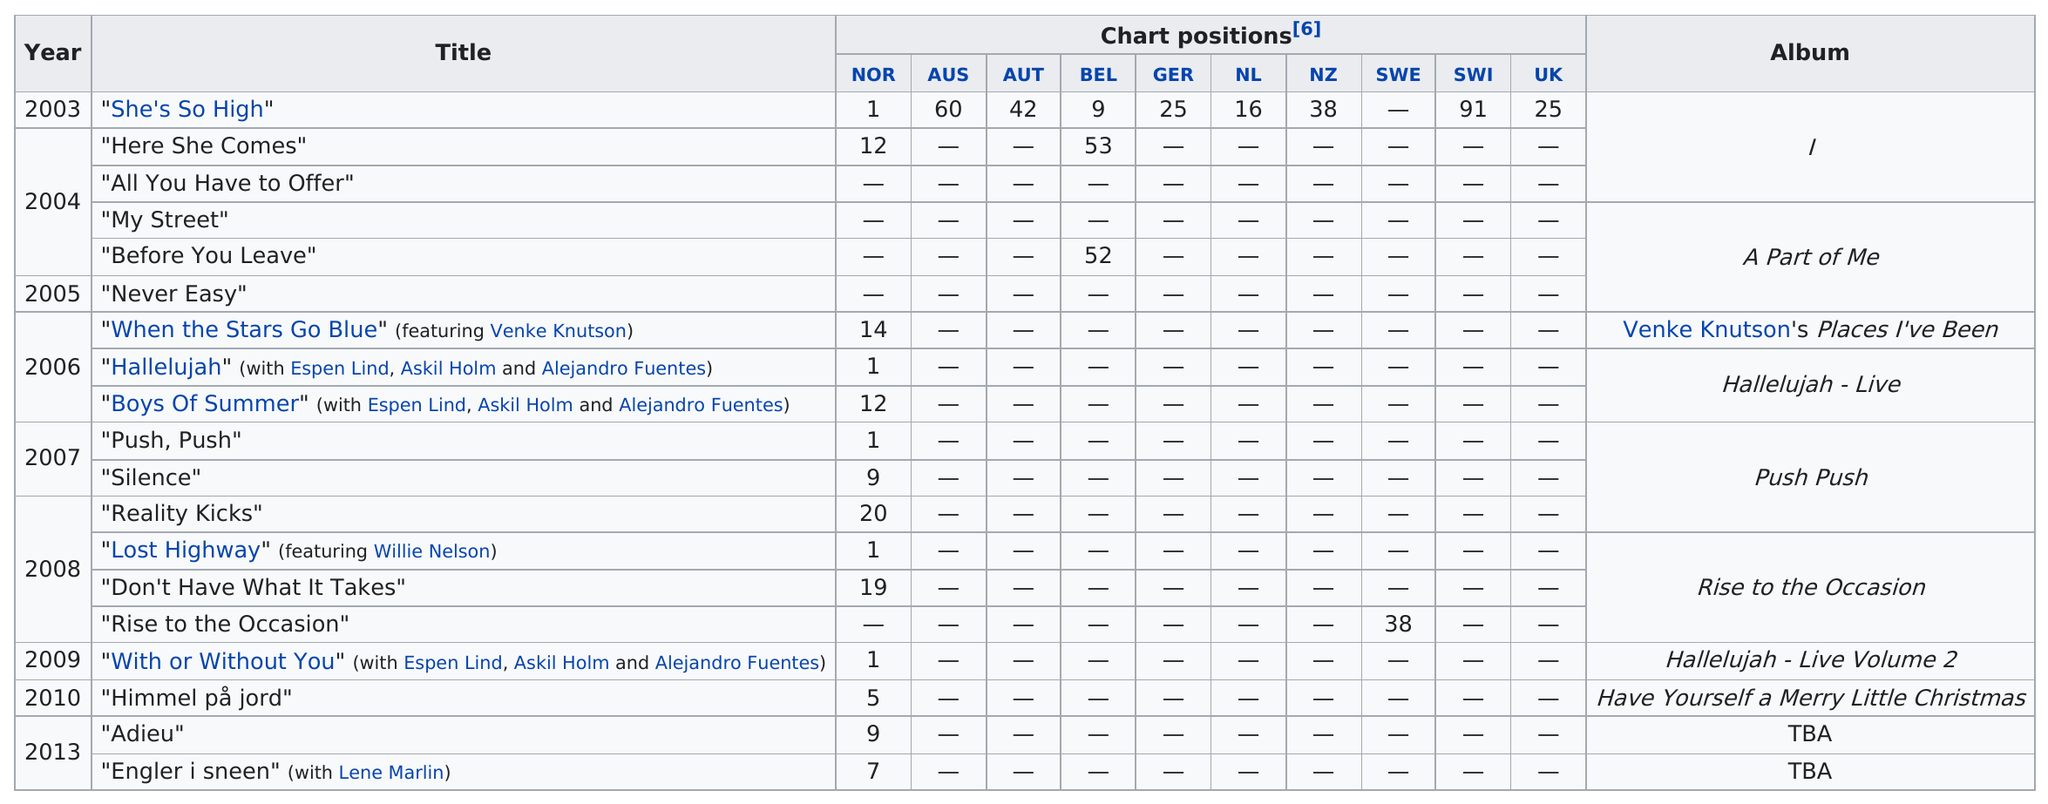Mention a couple of crucial points in this snapshot. The album "Hallelujah - Live Volume 2" was released in 2009. 